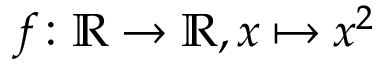<formula> <loc_0><loc_0><loc_500><loc_500>f \colon \mathbb { R } \rightarrow \mathbb { R } , x \mapsto x ^ { 2 }</formula> 